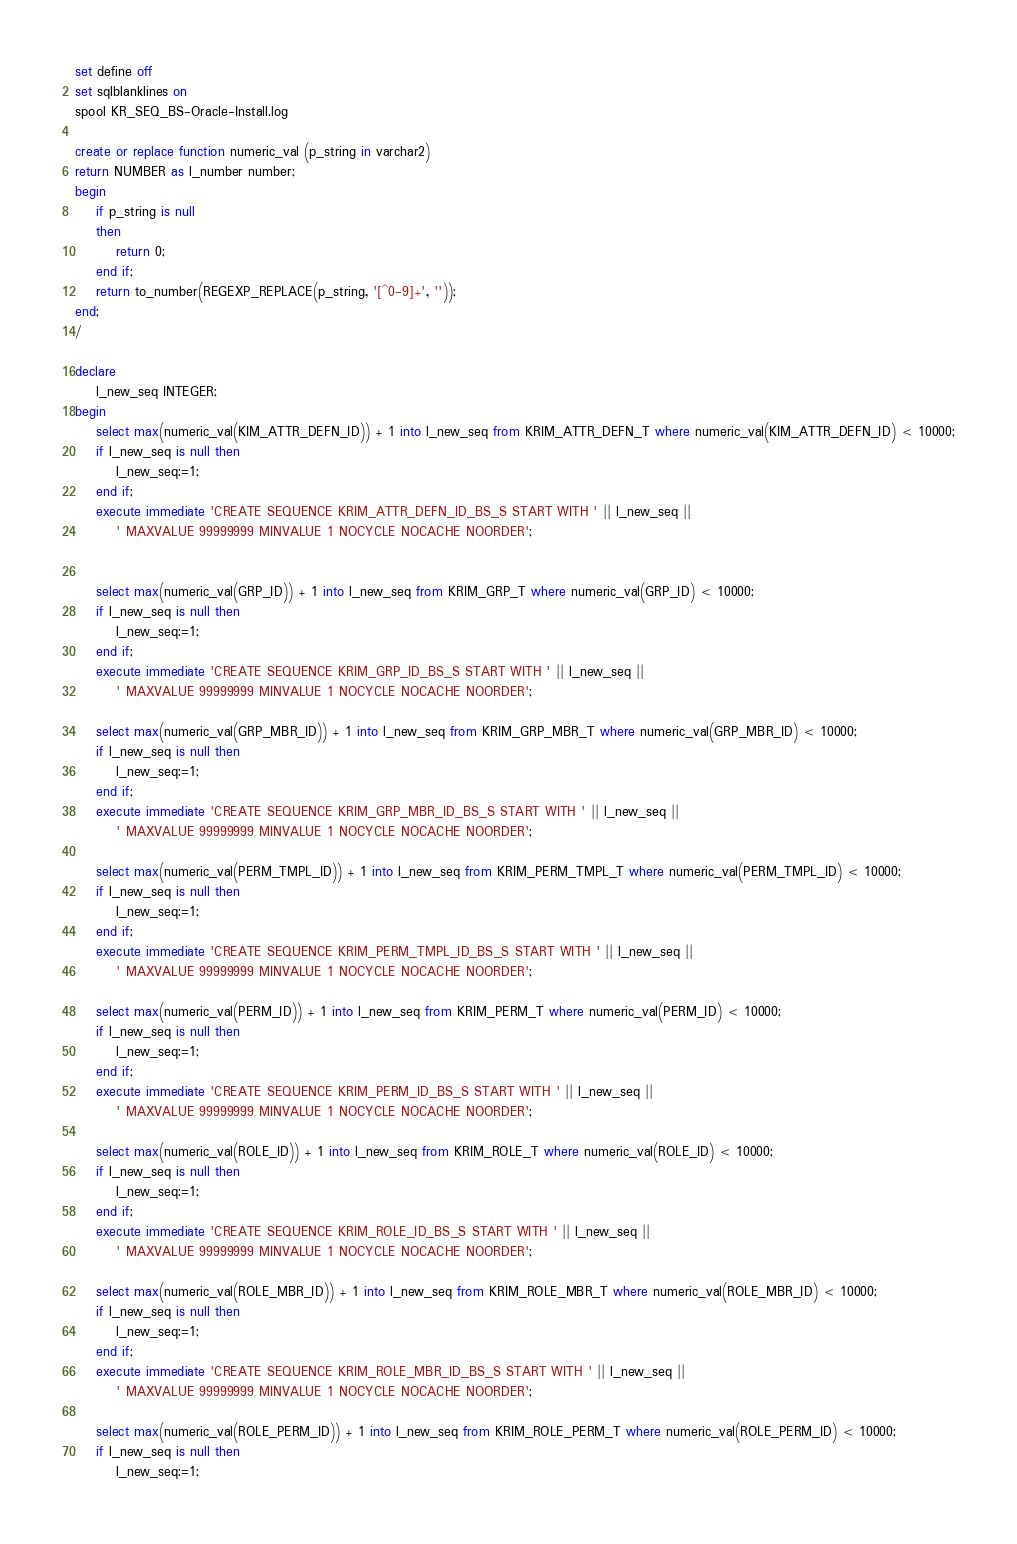Convert code to text. <code><loc_0><loc_0><loc_500><loc_500><_SQL_>set define off 
set sqlblanklines on 
spool KR_SEQ_BS-Oracle-Install.log

create or replace function numeric_val (p_string in varchar2) 
return NUMBER as l_number number;
begin
	if p_string is null
	then
		return 0;
	end if;
    return to_number(REGEXP_REPLACE(p_string, '[^0-9]+', ''));
end;
/

declare
	l_new_seq INTEGER;
begin
    select max(numeric_val(KIM_ATTR_DEFN_ID)) + 1 into l_new_seq from KRIM_ATTR_DEFN_T where numeric_val(KIM_ATTR_DEFN_ID) < 10000;
    if l_new_seq is null then
    	l_new_seq:=1;
    end if;
    execute immediate 'CREATE SEQUENCE KRIM_ATTR_DEFN_ID_BS_S START WITH ' || l_new_seq || 
        ' MAXVALUE 99999999 MINVALUE 1 NOCYCLE NOCACHE NOORDER';
    
        
    select max(numeric_val(GRP_ID)) + 1 into l_new_seq from KRIM_GRP_T where numeric_val(GRP_ID) < 10000;
    if l_new_seq is null then
    	l_new_seq:=1;
    end if;
    execute immediate 'CREATE SEQUENCE KRIM_GRP_ID_BS_S START WITH ' || l_new_seq || 
        ' MAXVALUE 99999999 MINVALUE 1 NOCYCLE NOCACHE NOORDER';

    select max(numeric_val(GRP_MBR_ID)) + 1 into l_new_seq from KRIM_GRP_MBR_T where numeric_val(GRP_MBR_ID) < 10000;
    if l_new_seq is null then
    	l_new_seq:=1;
    end if;
    execute immediate 'CREATE SEQUENCE KRIM_GRP_MBR_ID_BS_S START WITH ' || l_new_seq || 
        ' MAXVALUE 99999999 MINVALUE 1 NOCYCLE NOCACHE NOORDER';
    
    select max(numeric_val(PERM_TMPL_ID)) + 1 into l_new_seq from KRIM_PERM_TMPL_T where numeric_val(PERM_TMPL_ID) < 10000;
    if l_new_seq is null then
    	l_new_seq:=1;
    end if;
    execute immediate 'CREATE SEQUENCE KRIM_PERM_TMPL_ID_BS_S START WITH ' || l_new_seq || 
        ' MAXVALUE 99999999 MINVALUE 1 NOCYCLE NOCACHE NOORDER';

    select max(numeric_val(PERM_ID)) + 1 into l_new_seq from KRIM_PERM_T where numeric_val(PERM_ID) < 10000;
    if l_new_seq is null then
    	l_new_seq:=1;
    end if;
    execute immediate 'CREATE SEQUENCE KRIM_PERM_ID_BS_S START WITH ' || l_new_seq || 
        ' MAXVALUE 99999999 MINVALUE 1 NOCYCLE NOCACHE NOORDER';
    
    select max(numeric_val(ROLE_ID)) + 1 into l_new_seq from KRIM_ROLE_T where numeric_val(ROLE_ID) < 10000;
    if l_new_seq is null then
    	l_new_seq:=1;
    end if;
    execute immediate 'CREATE SEQUENCE KRIM_ROLE_ID_BS_S START WITH ' || l_new_seq || 
        ' MAXVALUE 99999999 MINVALUE 1 NOCYCLE NOCACHE NOORDER';
    
    select max(numeric_val(ROLE_MBR_ID)) + 1 into l_new_seq from KRIM_ROLE_MBR_T where numeric_val(ROLE_MBR_ID) < 10000;
    if l_new_seq is null then
    	l_new_seq:=1;
    end if;
    execute immediate 'CREATE SEQUENCE KRIM_ROLE_MBR_ID_BS_S START WITH ' || l_new_seq || 
        ' MAXVALUE 99999999 MINVALUE 1 NOCYCLE NOCACHE NOORDER';

	select max(numeric_val(ROLE_PERM_ID)) + 1 into l_new_seq from KRIM_ROLE_PERM_T where numeric_val(ROLE_PERM_ID) < 10000;
	if l_new_seq is null then
    	l_new_seq:=1;</code> 